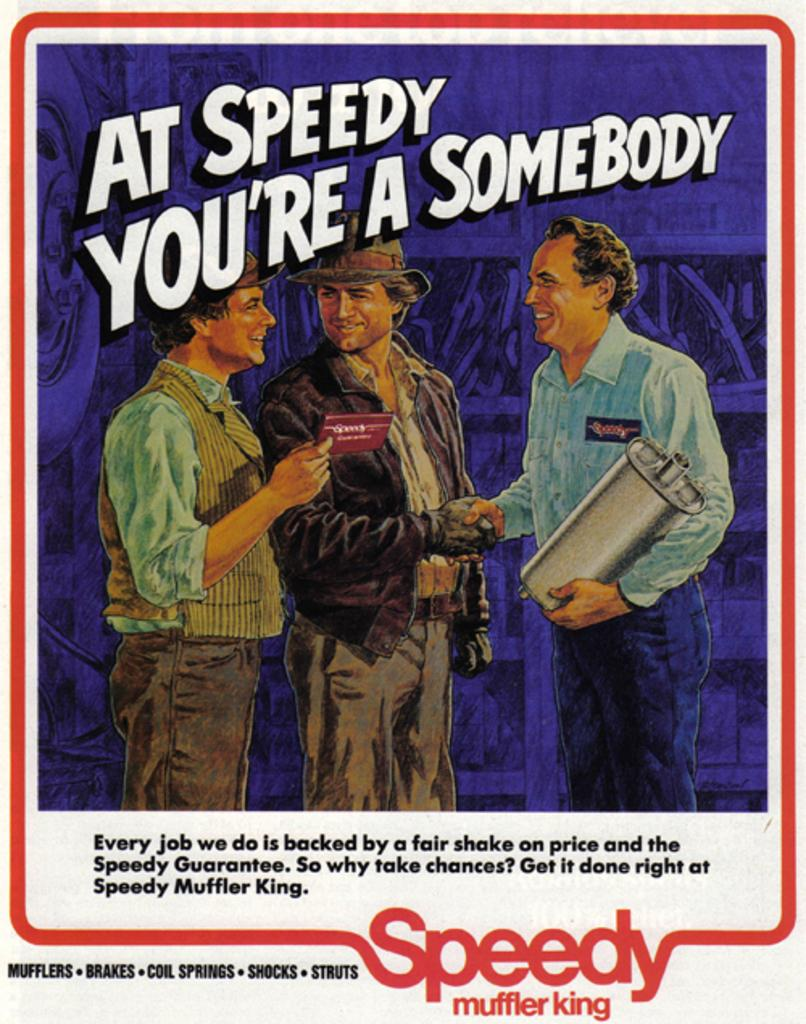What is present in the image that contains visual information? There is a poster in the image. What can be seen in the pictures on the poster? The pictures on the poster contain three people standing. What else is featured on the poster besides the images? There are letters written on the poster. Is there a rainstorm happening in the images on the poster? There is no indication of a rainstorm in the images on the poster; it features pictures of three people standing. What type of appliance is being used by the people in the images on the poster? There is no appliance visible in the images on the poster; it only shows three people standing. 